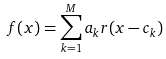<formula> <loc_0><loc_0><loc_500><loc_500>f ( x ) = \sum _ { k = 1 } ^ { M } a _ { k } r ( x - c _ { k } )</formula> 